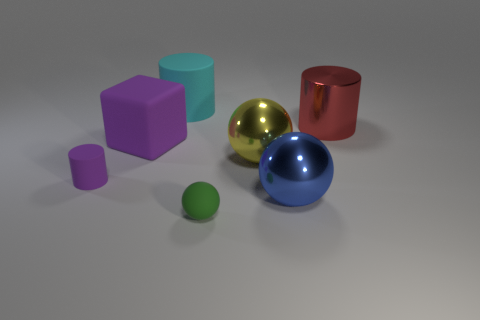Do the small matte cylinder and the large matte thing that is in front of the cyan rubber object have the same color?
Your answer should be compact. Yes. There is a big thing that is the same color as the small rubber cylinder; what is it made of?
Your response must be concise. Rubber. Are there any other things that have the same shape as the large purple rubber object?
Provide a short and direct response. No. There is a cylinder on the right side of the cyan rubber cylinder; is its size the same as the tiny purple thing?
Your answer should be compact. No. How many other objects are there of the same color as the big matte cube?
Give a very brief answer. 1. What is the material of the big object in front of the tiny rubber thing behind the tiny object on the right side of the cube?
Provide a short and direct response. Metal. What material is the cylinder on the right side of the big sphere behind the big blue metallic thing?
Offer a very short reply. Metal. Are there fewer big blue metallic things that are behind the small ball than objects?
Make the answer very short. Yes. The object behind the big red thing has what shape?
Make the answer very short. Cylinder. There is a green matte ball; does it have the same size as the matte cylinder that is on the left side of the cyan matte thing?
Keep it short and to the point. Yes. 